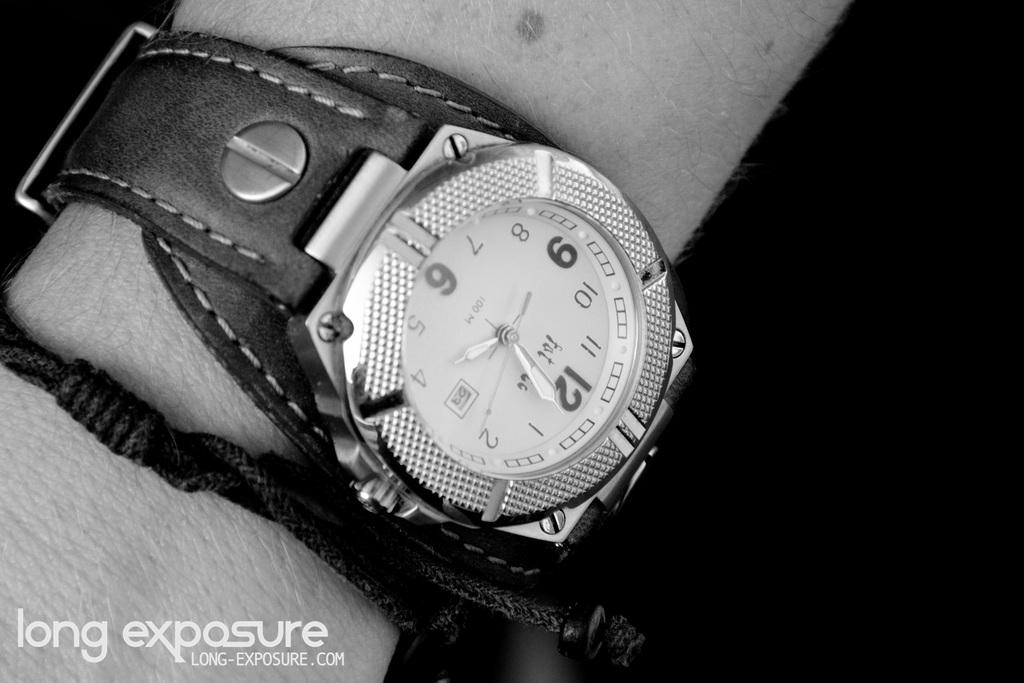What object is in the image that is used for telling time? There is a watch in the image that is used for telling time. Where is the watch located in the image? The watch is on a hand in the image. What else is visible near the watch in the image? There is a band beside the watch in the image. What type of wrench is being used to adjust the texture of the form in the image? There is no wrench, texture, or form present in the image; it only features a watch on a hand with a band beside it. 